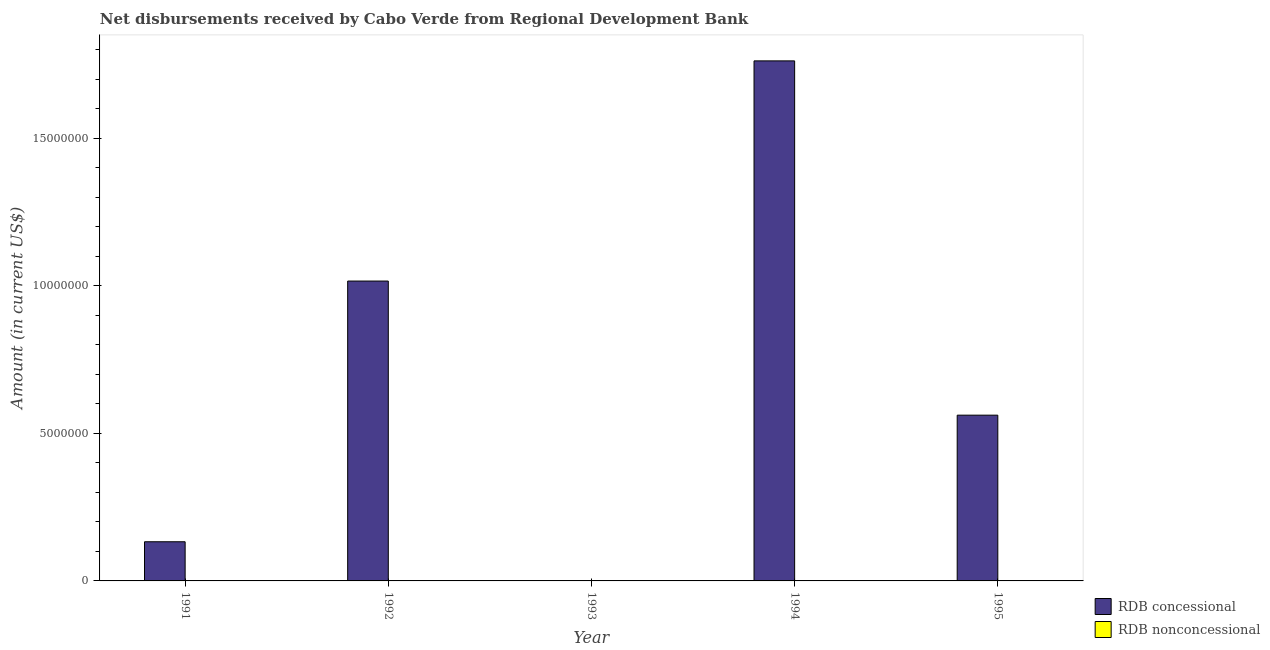How many bars are there on the 1st tick from the right?
Keep it short and to the point. 1. In how many cases, is the number of bars for a given year not equal to the number of legend labels?
Keep it short and to the point. 5. Across all years, what is the maximum net concessional disbursements from rdb?
Your response must be concise. 1.76e+07. In which year was the net concessional disbursements from rdb maximum?
Ensure brevity in your answer.  1994. What is the total net concessional disbursements from rdb in the graph?
Ensure brevity in your answer.  3.47e+07. What is the difference between the net concessional disbursements from rdb in 1991 and that in 1995?
Provide a succinct answer. -4.29e+06. What is the average net non concessional disbursements from rdb per year?
Keep it short and to the point. 0. In how many years, is the net concessional disbursements from rdb greater than 4000000 US$?
Ensure brevity in your answer.  3. What is the ratio of the net concessional disbursements from rdb in 1992 to that in 1994?
Offer a terse response. 0.58. Is the net concessional disbursements from rdb in 1992 less than that in 1995?
Offer a very short reply. No. What is the difference between the highest and the second highest net concessional disbursements from rdb?
Your answer should be compact. 7.46e+06. What is the difference between the highest and the lowest net concessional disbursements from rdb?
Provide a short and direct response. 1.76e+07. In how many years, is the net concessional disbursements from rdb greater than the average net concessional disbursements from rdb taken over all years?
Offer a terse response. 2. Is the sum of the net concessional disbursements from rdb in 1994 and 1995 greater than the maximum net non concessional disbursements from rdb across all years?
Offer a very short reply. Yes. Are all the bars in the graph horizontal?
Provide a succinct answer. No. How many years are there in the graph?
Ensure brevity in your answer.  5. Does the graph contain grids?
Keep it short and to the point. No. What is the title of the graph?
Provide a succinct answer. Net disbursements received by Cabo Verde from Regional Development Bank. What is the label or title of the Y-axis?
Your answer should be very brief. Amount (in current US$). What is the Amount (in current US$) in RDB concessional in 1991?
Provide a short and direct response. 1.33e+06. What is the Amount (in current US$) in RDB concessional in 1992?
Give a very brief answer. 1.02e+07. What is the Amount (in current US$) of RDB nonconcessional in 1992?
Keep it short and to the point. 0. What is the Amount (in current US$) in RDB concessional in 1993?
Offer a terse response. 0. What is the Amount (in current US$) of RDB nonconcessional in 1993?
Keep it short and to the point. 0. What is the Amount (in current US$) in RDB concessional in 1994?
Provide a succinct answer. 1.76e+07. What is the Amount (in current US$) of RDB concessional in 1995?
Provide a short and direct response. 5.62e+06. Across all years, what is the maximum Amount (in current US$) of RDB concessional?
Offer a very short reply. 1.76e+07. What is the total Amount (in current US$) in RDB concessional in the graph?
Make the answer very short. 3.47e+07. What is the difference between the Amount (in current US$) in RDB concessional in 1991 and that in 1992?
Your answer should be very brief. -8.83e+06. What is the difference between the Amount (in current US$) in RDB concessional in 1991 and that in 1994?
Give a very brief answer. -1.63e+07. What is the difference between the Amount (in current US$) in RDB concessional in 1991 and that in 1995?
Provide a succinct answer. -4.29e+06. What is the difference between the Amount (in current US$) in RDB concessional in 1992 and that in 1994?
Your answer should be very brief. -7.46e+06. What is the difference between the Amount (in current US$) in RDB concessional in 1992 and that in 1995?
Your answer should be very brief. 4.54e+06. What is the difference between the Amount (in current US$) in RDB concessional in 1994 and that in 1995?
Provide a succinct answer. 1.20e+07. What is the average Amount (in current US$) in RDB concessional per year?
Ensure brevity in your answer.  6.94e+06. What is the ratio of the Amount (in current US$) of RDB concessional in 1991 to that in 1992?
Your answer should be very brief. 0.13. What is the ratio of the Amount (in current US$) of RDB concessional in 1991 to that in 1994?
Your answer should be compact. 0.08. What is the ratio of the Amount (in current US$) of RDB concessional in 1991 to that in 1995?
Provide a succinct answer. 0.24. What is the ratio of the Amount (in current US$) in RDB concessional in 1992 to that in 1994?
Your answer should be compact. 0.58. What is the ratio of the Amount (in current US$) in RDB concessional in 1992 to that in 1995?
Your answer should be compact. 1.81. What is the ratio of the Amount (in current US$) of RDB concessional in 1994 to that in 1995?
Provide a short and direct response. 3.14. What is the difference between the highest and the second highest Amount (in current US$) of RDB concessional?
Your response must be concise. 7.46e+06. What is the difference between the highest and the lowest Amount (in current US$) of RDB concessional?
Provide a short and direct response. 1.76e+07. 